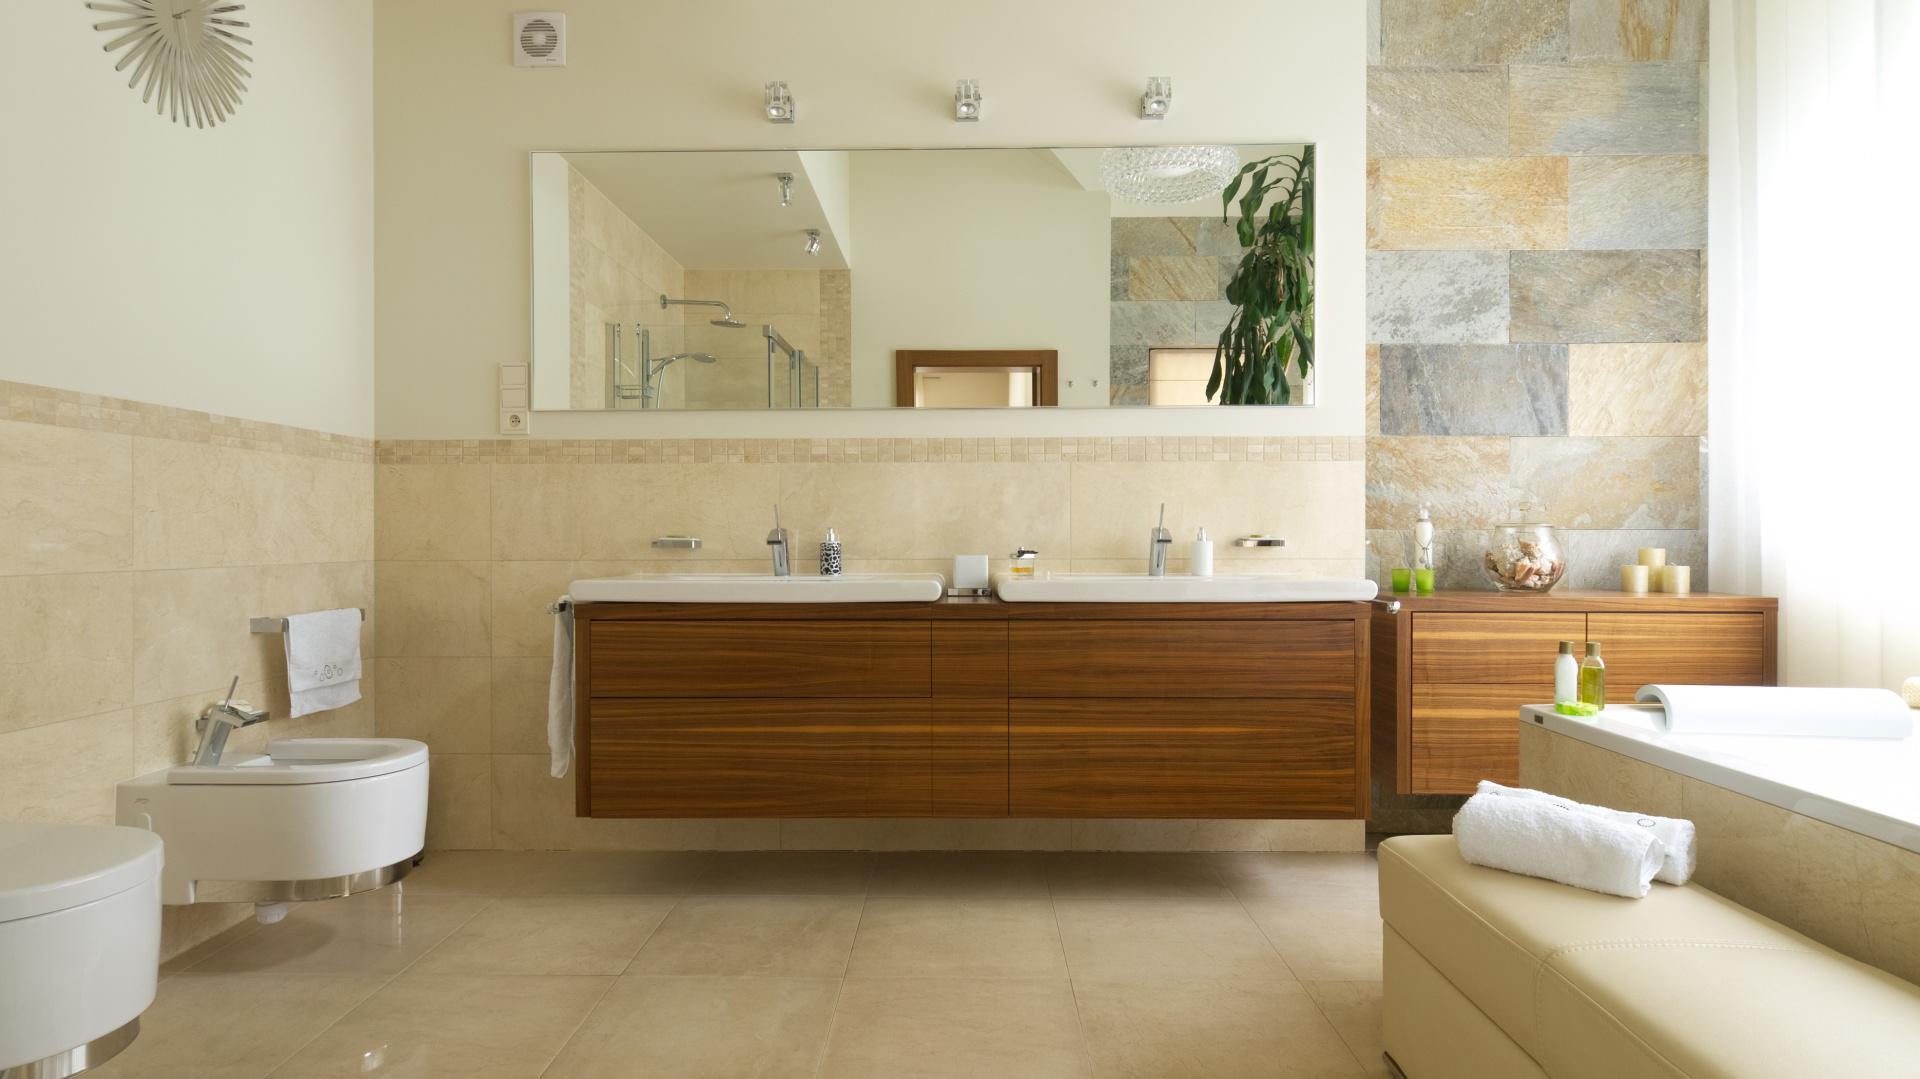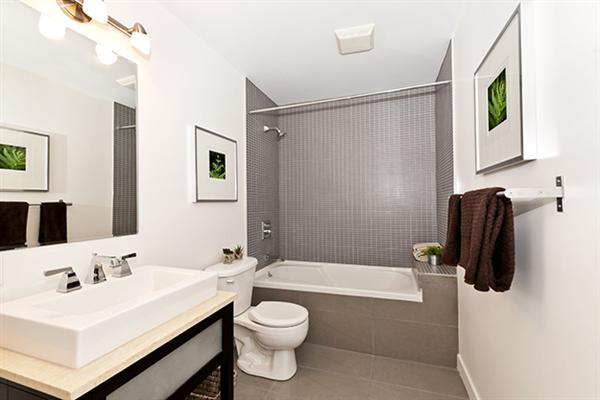The first image is the image on the left, the second image is the image on the right. Analyze the images presented: Is the assertion "One bathroom has a long wall-mounted black vanity with separate white sinks, and the other bathroom has a round bathtub and double square sinks." valid? Answer yes or no. No. The first image is the image on the left, the second image is the image on the right. For the images shown, is this caption "One of the sinks is mostly wood paneled." true? Answer yes or no. Yes. 